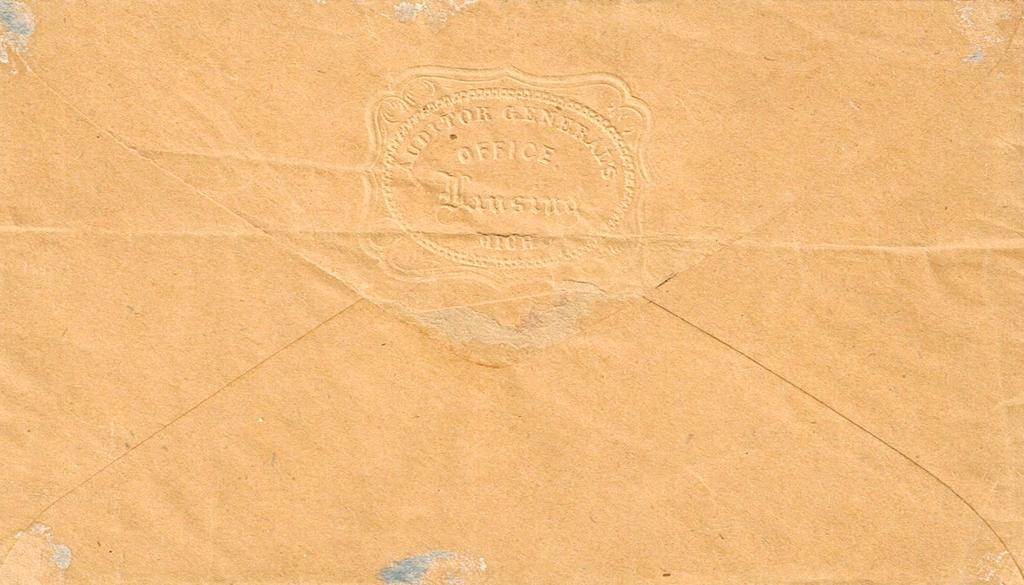What does the envelope say?
Give a very brief answer. Auditor general's office. 